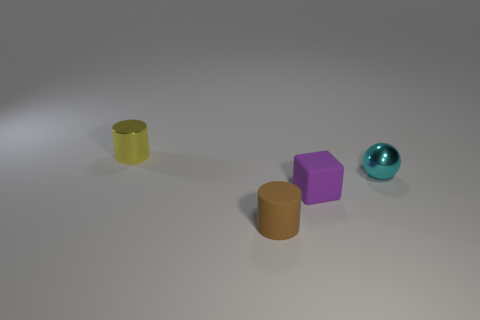Subtract all yellow cylinders. How many cylinders are left? 1 Subtract 1 blocks. How many blocks are left? 0 Subtract all balls. How many objects are left? 3 Add 1 small purple things. How many objects exist? 5 Subtract 0 purple cylinders. How many objects are left? 4 Subtract all gray cylinders. Subtract all gray cubes. How many cylinders are left? 2 Subtract all small rubber things. Subtract all metal spheres. How many objects are left? 1 Add 4 small things. How many small things are left? 8 Add 3 big cyan matte blocks. How many big cyan matte blocks exist? 3 